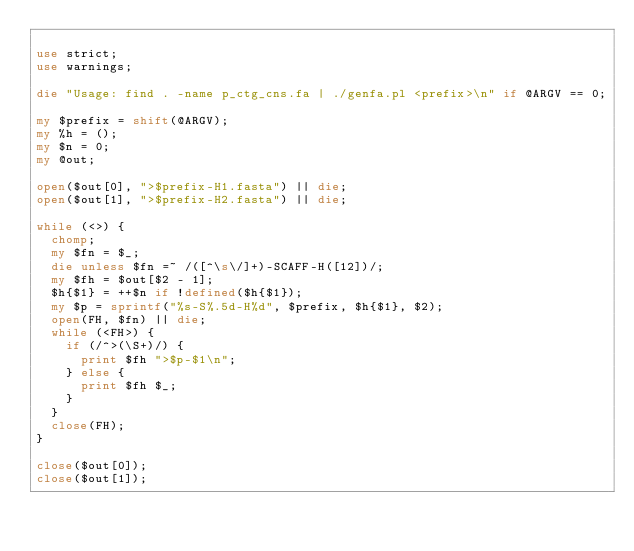<code> <loc_0><loc_0><loc_500><loc_500><_Perl_>
use strict;
use warnings;

die "Usage: find . -name p_ctg_cns.fa | ./genfa.pl <prefix>\n" if @ARGV == 0;

my $prefix = shift(@ARGV);
my %h = ();
my $n = 0;
my @out;

open($out[0], ">$prefix-H1.fasta") || die;
open($out[1], ">$prefix-H2.fasta") || die;

while (<>) {
	chomp;
	my $fn = $_;
	die unless $fn =~ /([^\s\/]+)-SCAFF-H([12])/;
	my $fh = $out[$2 - 1];
	$h{$1} = ++$n if !defined($h{$1});
	my $p = sprintf("%s-S%.5d-H%d", $prefix, $h{$1}, $2);
	open(FH, $fn) || die;
	while (<FH>) {
		if (/^>(\S+)/) {
			print $fh ">$p-$1\n";
		} else {
			print $fh $_;
		}
	}
	close(FH);
}

close($out[0]);
close($out[1]);
</code> 